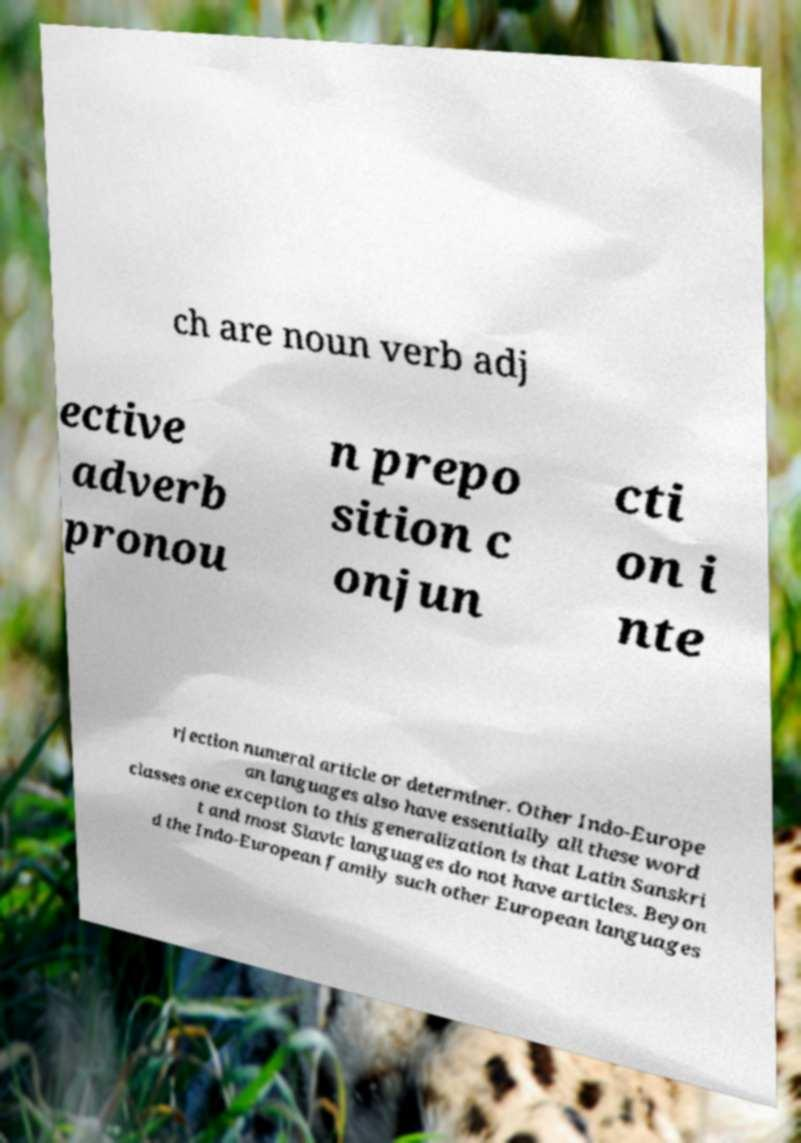There's text embedded in this image that I need extracted. Can you transcribe it verbatim? ch are noun verb adj ective adverb pronou n prepo sition c onjun cti on i nte rjection numeral article or determiner. Other Indo-Europe an languages also have essentially all these word classes one exception to this generalization is that Latin Sanskri t and most Slavic languages do not have articles. Beyon d the Indo-European family such other European languages 